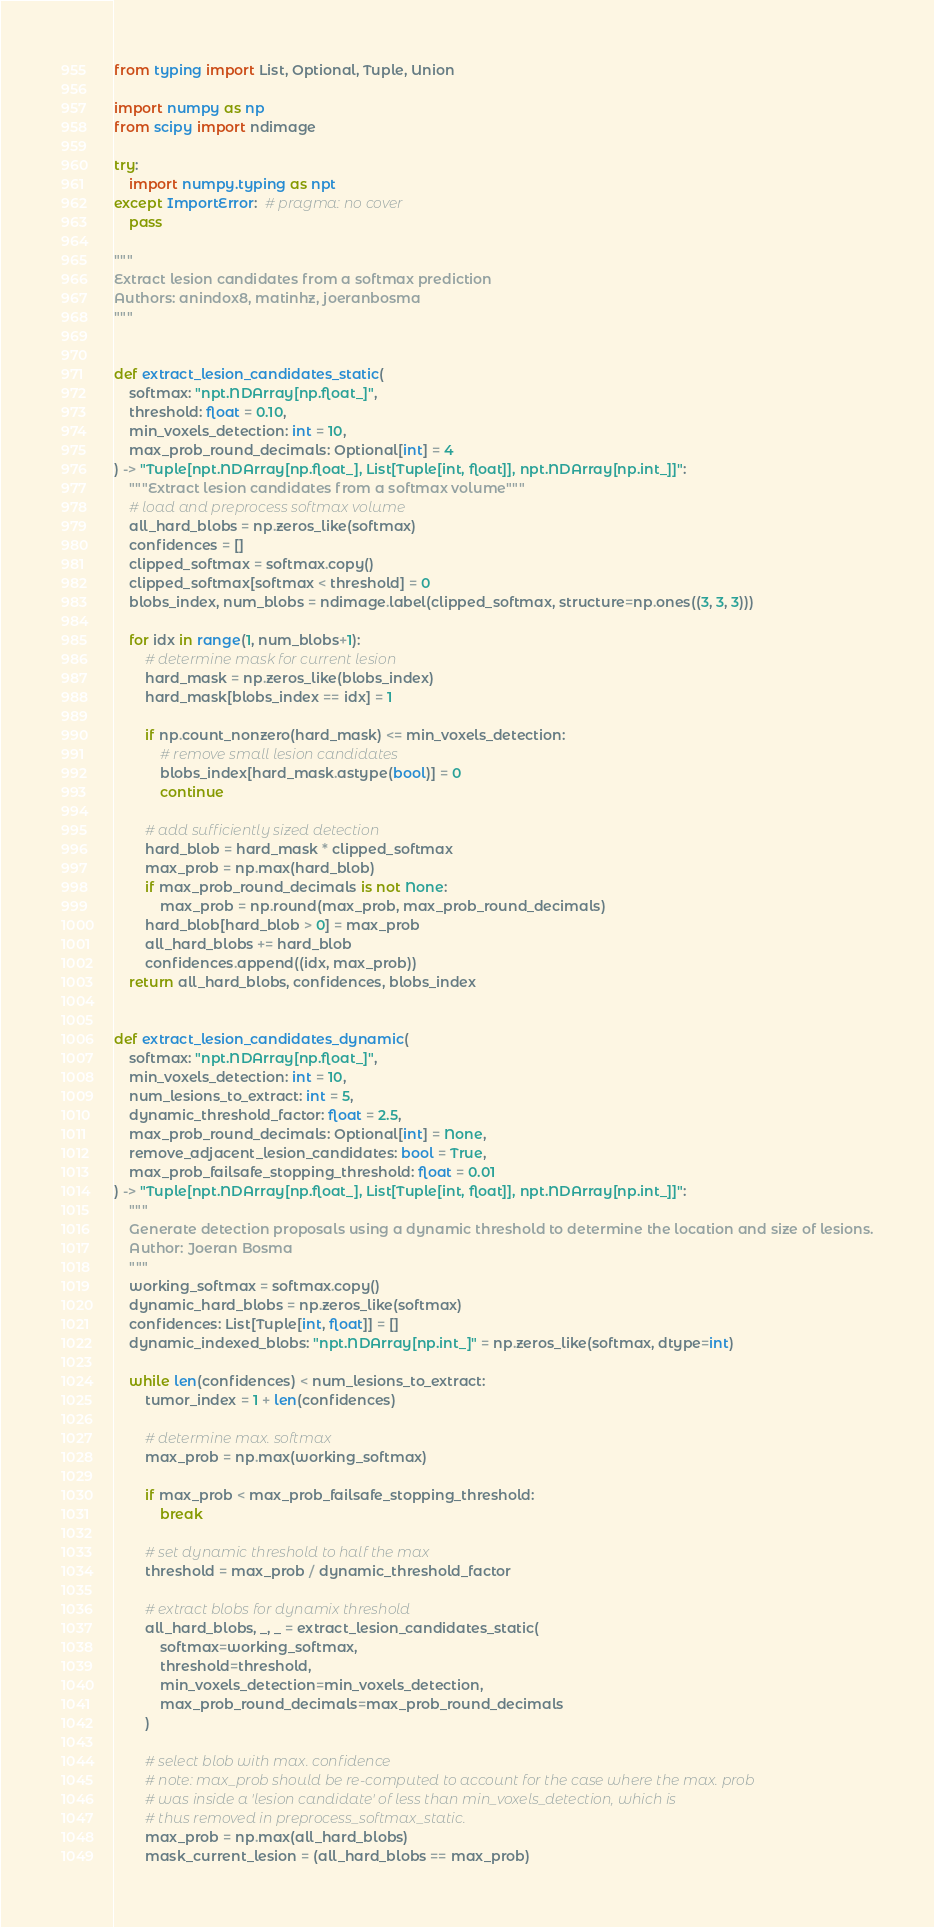Convert code to text. <code><loc_0><loc_0><loc_500><loc_500><_Python_>from typing import List, Optional, Tuple, Union

import numpy as np
from scipy import ndimage

try:
    import numpy.typing as npt
except ImportError:  # pragma: no cover
    pass

"""
Extract lesion candidates from a softmax prediction
Authors: anindox8, matinhz, joeranbosma
"""


def extract_lesion_candidates_static(
    softmax: "npt.NDArray[np.float_]",
    threshold: float = 0.10,
    min_voxels_detection: int = 10,
    max_prob_round_decimals: Optional[int] = 4
) -> "Tuple[npt.NDArray[np.float_], List[Tuple[int, float]], npt.NDArray[np.int_]]":
    """Extract lesion candidates from a softmax volume"""
    # load and preprocess softmax volume
    all_hard_blobs = np.zeros_like(softmax)
    confidences = []
    clipped_softmax = softmax.copy()
    clipped_softmax[softmax < threshold] = 0
    blobs_index, num_blobs = ndimage.label(clipped_softmax, structure=np.ones((3, 3, 3)))

    for idx in range(1, num_blobs+1):
        # determine mask for current lesion
        hard_mask = np.zeros_like(blobs_index)
        hard_mask[blobs_index == idx] = 1

        if np.count_nonzero(hard_mask) <= min_voxels_detection:
            # remove small lesion candidates
            blobs_index[hard_mask.astype(bool)] = 0
            continue

        # add sufficiently sized detection
        hard_blob = hard_mask * clipped_softmax
        max_prob = np.max(hard_blob)
        if max_prob_round_decimals is not None:
            max_prob = np.round(max_prob, max_prob_round_decimals)
        hard_blob[hard_blob > 0] = max_prob
        all_hard_blobs += hard_blob
        confidences.append((idx, max_prob))
    return all_hard_blobs, confidences, blobs_index


def extract_lesion_candidates_dynamic(
    softmax: "npt.NDArray[np.float_]",
    min_voxels_detection: int = 10,
    num_lesions_to_extract: int = 5,
    dynamic_threshold_factor: float = 2.5,
    max_prob_round_decimals: Optional[int] = None,
    remove_adjacent_lesion_candidates: bool = True,
    max_prob_failsafe_stopping_threshold: float = 0.01
) -> "Tuple[npt.NDArray[np.float_], List[Tuple[int, float]], npt.NDArray[np.int_]]":
    """
    Generate detection proposals using a dynamic threshold to determine the location and size of lesions.
    Author: Joeran Bosma
    """
    working_softmax = softmax.copy()
    dynamic_hard_blobs = np.zeros_like(softmax)
    confidences: List[Tuple[int, float]] = []
    dynamic_indexed_blobs: "npt.NDArray[np.int_]" = np.zeros_like(softmax, dtype=int)

    while len(confidences) < num_lesions_to_extract:
        tumor_index = 1 + len(confidences)

        # determine max. softmax
        max_prob = np.max(working_softmax)

        if max_prob < max_prob_failsafe_stopping_threshold:
            break

        # set dynamic threshold to half the max
        threshold = max_prob / dynamic_threshold_factor

        # extract blobs for dynamix threshold
        all_hard_blobs, _, _ = extract_lesion_candidates_static(
            softmax=working_softmax,
            threshold=threshold,
            min_voxels_detection=min_voxels_detection,
            max_prob_round_decimals=max_prob_round_decimals
        )

        # select blob with max. confidence
        # note: max_prob should be re-computed to account for the case where the max. prob
        # was inside a 'lesion candidate' of less than min_voxels_detection, which is
        # thus removed in preprocess_softmax_static.
        max_prob = np.max(all_hard_blobs)
        mask_current_lesion = (all_hard_blobs == max_prob)
</code> 